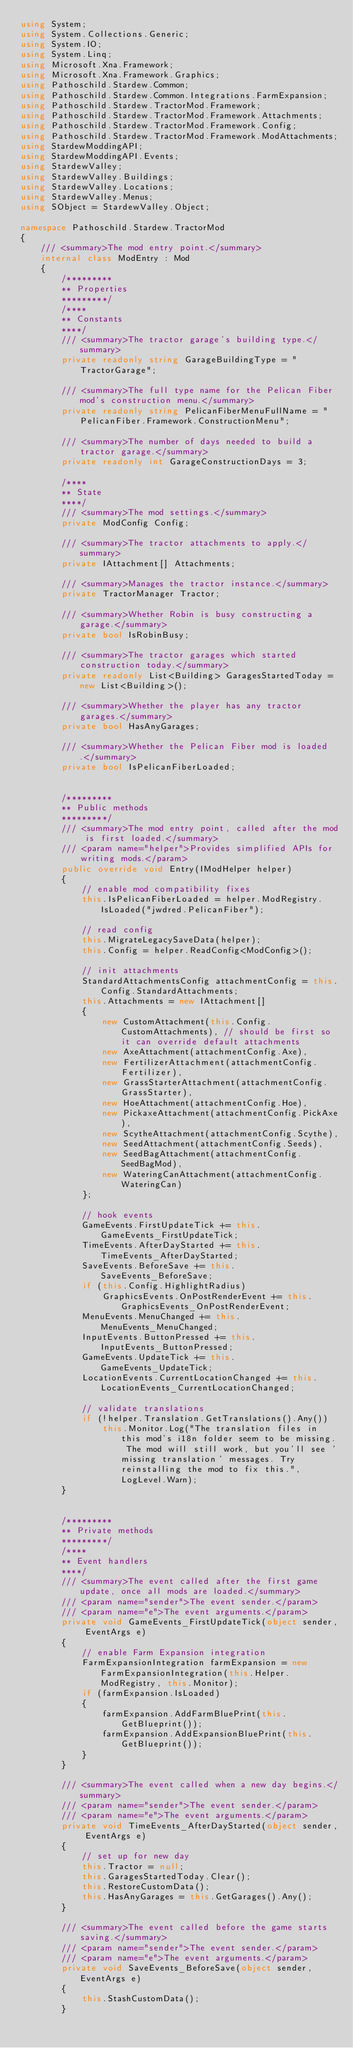Convert code to text. <code><loc_0><loc_0><loc_500><loc_500><_C#_>using System;
using System.Collections.Generic;
using System.IO;
using System.Linq;
using Microsoft.Xna.Framework;
using Microsoft.Xna.Framework.Graphics;
using Pathoschild.Stardew.Common;
using Pathoschild.Stardew.Common.Integrations.FarmExpansion;
using Pathoschild.Stardew.TractorMod.Framework;
using Pathoschild.Stardew.TractorMod.Framework.Attachments;
using Pathoschild.Stardew.TractorMod.Framework.Config;
using Pathoschild.Stardew.TractorMod.Framework.ModAttachments;
using StardewModdingAPI;
using StardewModdingAPI.Events;
using StardewValley;
using StardewValley.Buildings;
using StardewValley.Locations;
using StardewValley.Menus;
using SObject = StardewValley.Object;

namespace Pathoschild.Stardew.TractorMod
{
    /// <summary>The mod entry point.</summary>
    internal class ModEntry : Mod
    {
        /*********
        ** Properties
        *********/
        /****
        ** Constants
        ****/
        /// <summary>The tractor garage's building type.</summary>
        private readonly string GarageBuildingType = "TractorGarage";

        /// <summary>The full type name for the Pelican Fiber mod's construction menu.</summary>
        private readonly string PelicanFiberMenuFullName = "PelicanFiber.Framework.ConstructionMenu";

        /// <summary>The number of days needed to build a tractor garage.</summary>
        private readonly int GarageConstructionDays = 3;

        /****
        ** State
        ****/
        /// <summary>The mod settings.</summary>
        private ModConfig Config;

        /// <summary>The tractor attachments to apply.</summary>
        private IAttachment[] Attachments;

        /// <summary>Manages the tractor instance.</summary>
        private TractorManager Tractor;

        /// <summary>Whether Robin is busy constructing a garage.</summary>
        private bool IsRobinBusy;

        /// <summary>The tractor garages which started construction today.</summary>
        private readonly List<Building> GaragesStartedToday = new List<Building>();

        /// <summary>Whether the player has any tractor garages.</summary>
        private bool HasAnyGarages;

        /// <summary>Whether the Pelican Fiber mod is loaded.</summary>
        private bool IsPelicanFiberLoaded;


        /*********
        ** Public methods
        *********/
        /// <summary>The mod entry point, called after the mod is first loaded.</summary>
        /// <param name="helper">Provides simplified APIs for writing mods.</param>
        public override void Entry(IModHelper helper)
        {
            // enable mod compatibility fixes
            this.IsPelicanFiberLoaded = helper.ModRegistry.IsLoaded("jwdred.PelicanFiber");

            // read config
            this.MigrateLegacySaveData(helper);
            this.Config = helper.ReadConfig<ModConfig>();

            // init attachments
            StandardAttachmentsConfig attachmentConfig = this.Config.StandardAttachments;
            this.Attachments = new IAttachment[]
            {
                new CustomAttachment(this.Config.CustomAttachments), // should be first so it can override default attachments
                new AxeAttachment(attachmentConfig.Axe),
                new FertilizerAttachment(attachmentConfig.Fertilizer),
                new GrassStarterAttachment(attachmentConfig.GrassStarter),
                new HoeAttachment(attachmentConfig.Hoe),
                new PickaxeAttachment(attachmentConfig.PickAxe),
                new ScytheAttachment(attachmentConfig.Scythe),
                new SeedAttachment(attachmentConfig.Seeds),
                new SeedBagAttachment(attachmentConfig.SeedBagMod),
                new WateringCanAttachment(attachmentConfig.WateringCan)
            };

            // hook events
            GameEvents.FirstUpdateTick += this.GameEvents_FirstUpdateTick;
            TimeEvents.AfterDayStarted += this.TimeEvents_AfterDayStarted;
            SaveEvents.BeforeSave += this.SaveEvents_BeforeSave;
            if (this.Config.HighlightRadius)
                GraphicsEvents.OnPostRenderEvent += this.GraphicsEvents_OnPostRenderEvent;
            MenuEvents.MenuChanged += this.MenuEvents_MenuChanged;
            InputEvents.ButtonPressed += this.InputEvents_ButtonPressed;
            GameEvents.UpdateTick += this.GameEvents_UpdateTick;
            LocationEvents.CurrentLocationChanged += this.LocationEvents_CurrentLocationChanged;

            // validate translations
            if (!helper.Translation.GetTranslations().Any())
                this.Monitor.Log("The translation files in this mod's i18n folder seem to be missing. The mod will still work, but you'll see 'missing translation' messages. Try reinstalling the mod to fix this.", LogLevel.Warn);
        }


        /*********
        ** Private methods
        *********/
        /****
        ** Event handlers
        ****/
        /// <summary>The event called after the first game update, once all mods are loaded.</summary>
        /// <param name="sender">The event sender.</param>
        /// <param name="e">The event arguments.</param>
        private void GameEvents_FirstUpdateTick(object sender, EventArgs e)
        {
            // enable Farm Expansion integration
            FarmExpansionIntegration farmExpansion = new FarmExpansionIntegration(this.Helper.ModRegistry, this.Monitor);
            if (farmExpansion.IsLoaded)
            {
                farmExpansion.AddFarmBluePrint(this.GetBlueprint());
                farmExpansion.AddExpansionBluePrint(this.GetBlueprint());
            }
        }

        /// <summary>The event called when a new day begins.</summary>
        /// <param name="sender">The event sender.</param>
        /// <param name="e">The event arguments.</param>
        private void TimeEvents_AfterDayStarted(object sender, EventArgs e)
        {
            // set up for new day
            this.Tractor = null;
            this.GaragesStartedToday.Clear();
            this.RestoreCustomData();
            this.HasAnyGarages = this.GetGarages().Any();
        }

        /// <summary>The event called before the game starts saving.</summary>
        /// <param name="sender">The event sender.</param>
        /// <param name="e">The event arguments.</param>
        private void SaveEvents_BeforeSave(object sender, EventArgs e)
        {
            this.StashCustomData();
        }
</code> 